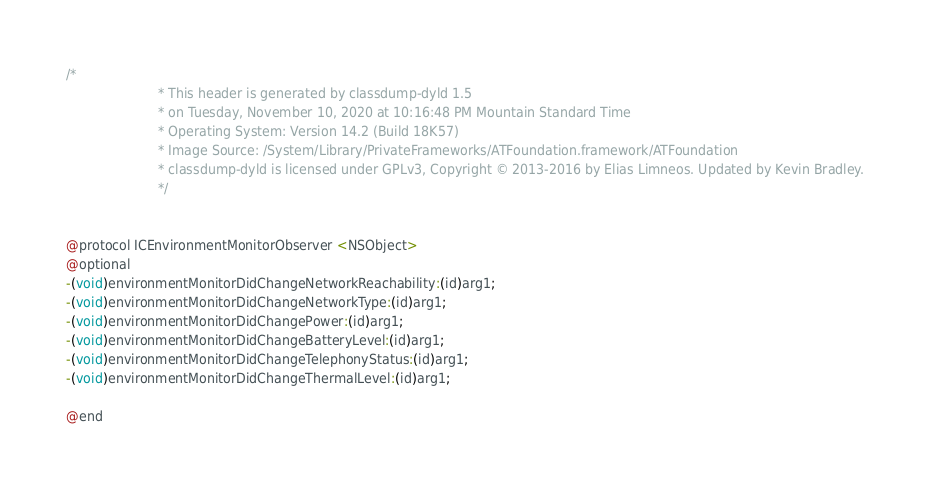Convert code to text. <code><loc_0><loc_0><loc_500><loc_500><_C_>/*
                       * This header is generated by classdump-dyld 1.5
                       * on Tuesday, November 10, 2020 at 10:16:48 PM Mountain Standard Time
                       * Operating System: Version 14.2 (Build 18K57)
                       * Image Source: /System/Library/PrivateFrameworks/ATFoundation.framework/ATFoundation
                       * classdump-dyld is licensed under GPLv3, Copyright © 2013-2016 by Elias Limneos. Updated by Kevin Bradley.
                       */


@protocol ICEnvironmentMonitorObserver <NSObject>
@optional
-(void)environmentMonitorDidChangeNetworkReachability:(id)arg1;
-(void)environmentMonitorDidChangeNetworkType:(id)arg1;
-(void)environmentMonitorDidChangePower:(id)arg1;
-(void)environmentMonitorDidChangeBatteryLevel:(id)arg1;
-(void)environmentMonitorDidChangeTelephonyStatus:(id)arg1;
-(void)environmentMonitorDidChangeThermalLevel:(id)arg1;

@end

</code> 